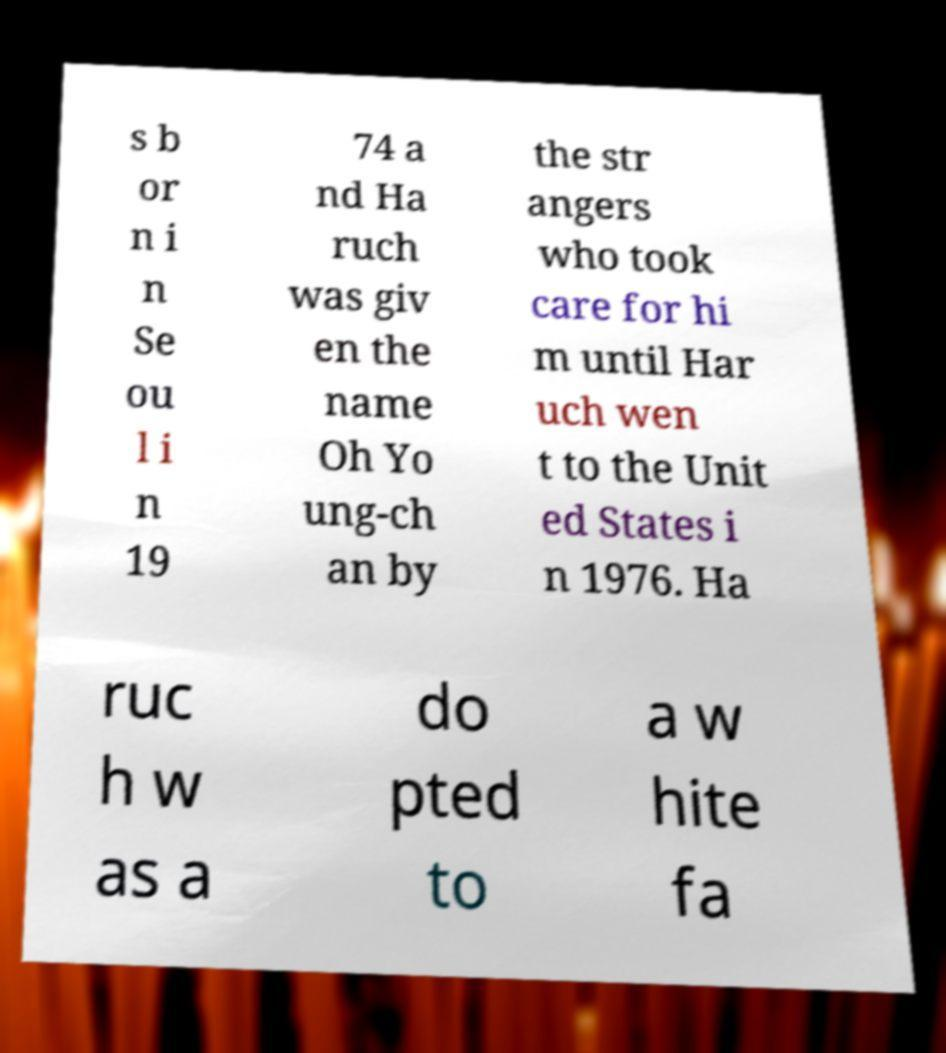There's text embedded in this image that I need extracted. Can you transcribe it verbatim? s b or n i n Se ou l i n 19 74 a nd Ha ruch was giv en the name Oh Yo ung-ch an by the str angers who took care for hi m until Har uch wen t to the Unit ed States i n 1976. Ha ruc h w as a do pted to a w hite fa 